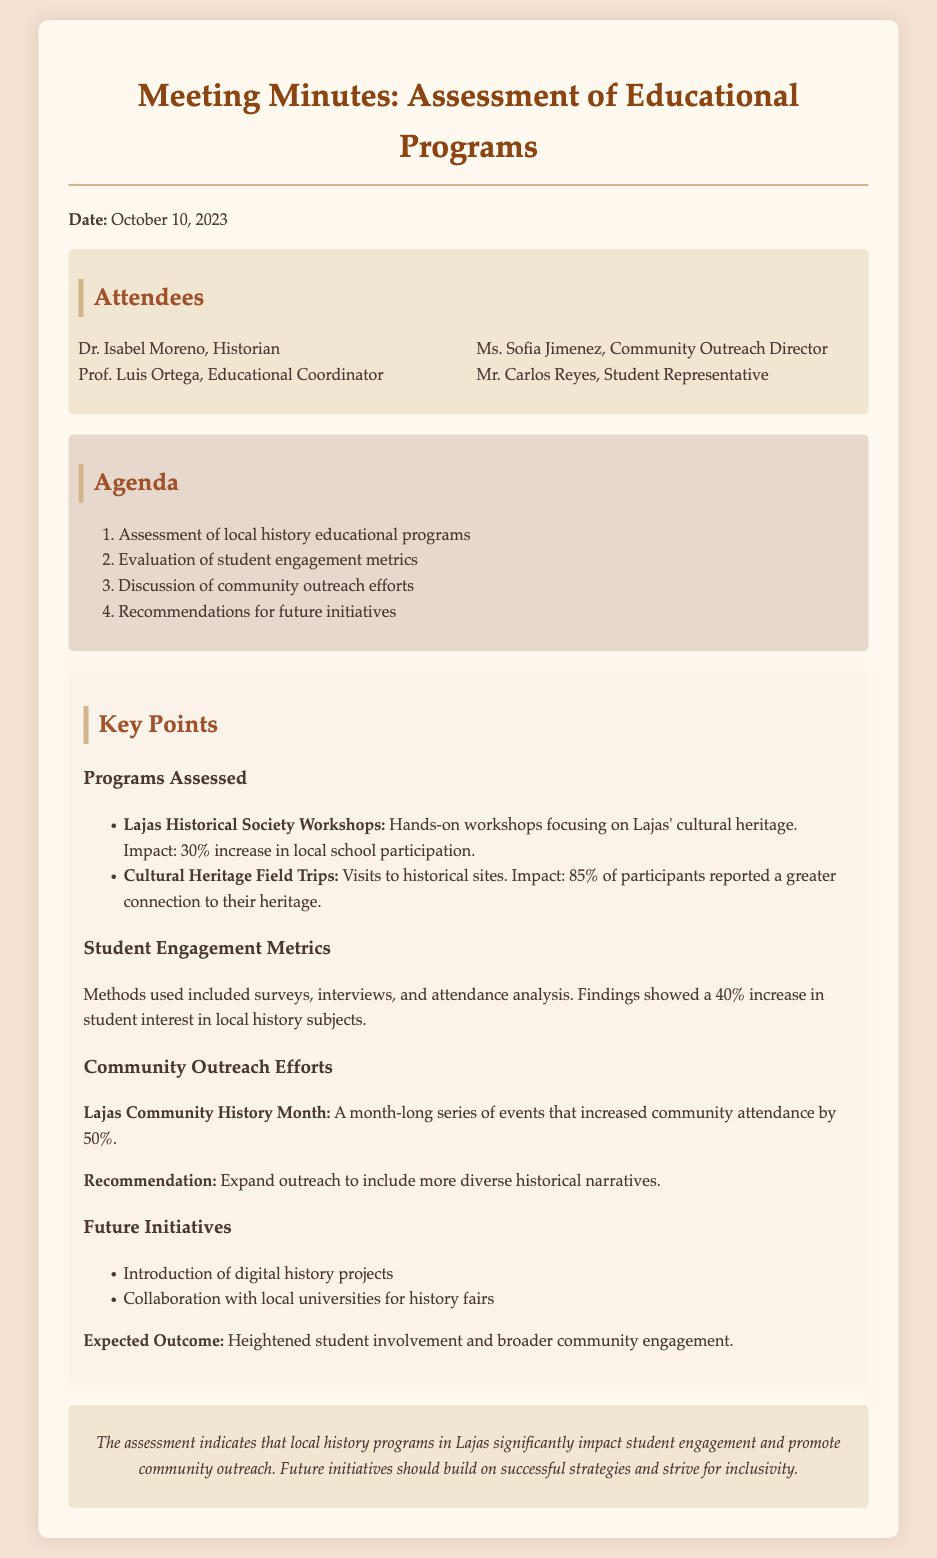What was the date of the meeting? The date of the meeting is explicitly mentioned in the document.
Answer: October 10, 2023 Who is the Community Outreach Director? The document provides a list of attendees along with their titles.
Answer: Ms. Sofia Jimenez How much did local school participation increase for workshops? The increase in local school participation for workshops is stated in the document.
Answer: 30% What percentage of participants felt a greater connection to their heritage after cultural field trips? The document mentions specific participant feedback regarding field trips.
Answer: 85% What is one of the recommendations mentioned for community outreach efforts? The document outlines a recommendation in the section about community outreach efforts.
Answer: Expand outreach to include more diverse historical narratives What methods were used to assess student engagement? The document lists specific methods used for the assessment in the student engagement metrics section.
Answer: Surveys, interviews, and attendance analysis How did attendance change during Lajas Community History Month? The document includes information about the impact on attendance during events in Lajas Community History Month.
Answer: 50% increase What is one future initiative mentioned for history programs? The document discusses future initiatives in the last section.
Answer: Introduction of digital history projects 